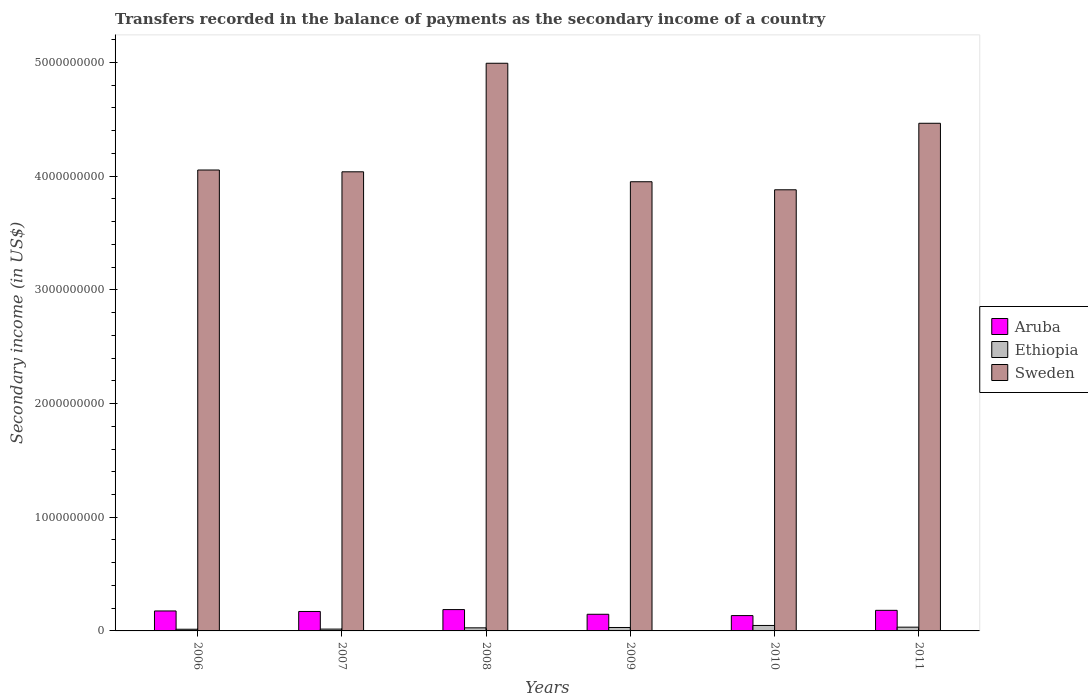How many groups of bars are there?
Offer a very short reply. 6. Are the number of bars per tick equal to the number of legend labels?
Keep it short and to the point. Yes. How many bars are there on the 4th tick from the right?
Keep it short and to the point. 3. What is the secondary income of in Ethiopia in 2007?
Make the answer very short. 1.60e+07. Across all years, what is the maximum secondary income of in Ethiopia?
Your answer should be very brief. 4.80e+07. Across all years, what is the minimum secondary income of in Ethiopia?
Give a very brief answer. 1.48e+07. In which year was the secondary income of in Sweden minimum?
Your response must be concise. 2010. What is the total secondary income of in Ethiopia in the graph?
Offer a very short reply. 1.69e+08. What is the difference between the secondary income of in Sweden in 2006 and that in 2010?
Ensure brevity in your answer.  1.74e+08. What is the difference between the secondary income of in Ethiopia in 2007 and the secondary income of in Aruba in 2010?
Offer a very short reply. -1.19e+08. What is the average secondary income of in Sweden per year?
Give a very brief answer. 4.23e+09. In the year 2009, what is the difference between the secondary income of in Aruba and secondary income of in Ethiopia?
Ensure brevity in your answer.  1.16e+08. In how many years, is the secondary income of in Aruba greater than 4200000000 US$?
Give a very brief answer. 0. What is the ratio of the secondary income of in Sweden in 2006 to that in 2011?
Provide a succinct answer. 0.91. Is the difference between the secondary income of in Aruba in 2007 and 2011 greater than the difference between the secondary income of in Ethiopia in 2007 and 2011?
Ensure brevity in your answer.  Yes. What is the difference between the highest and the second highest secondary income of in Ethiopia?
Your response must be concise. 1.49e+07. What is the difference between the highest and the lowest secondary income of in Aruba?
Your answer should be compact. 5.27e+07. In how many years, is the secondary income of in Aruba greater than the average secondary income of in Aruba taken over all years?
Provide a succinct answer. 4. Is the sum of the secondary income of in Aruba in 2008 and 2009 greater than the maximum secondary income of in Sweden across all years?
Ensure brevity in your answer.  No. What does the 3rd bar from the right in 2009 represents?
Provide a succinct answer. Aruba. Is it the case that in every year, the sum of the secondary income of in Sweden and secondary income of in Ethiopia is greater than the secondary income of in Aruba?
Your answer should be compact. Yes. Are all the bars in the graph horizontal?
Your answer should be very brief. No. How many years are there in the graph?
Keep it short and to the point. 6. Does the graph contain any zero values?
Offer a very short reply. No. How many legend labels are there?
Offer a terse response. 3. How are the legend labels stacked?
Ensure brevity in your answer.  Vertical. What is the title of the graph?
Your answer should be compact. Transfers recorded in the balance of payments as the secondary income of a country. What is the label or title of the X-axis?
Provide a short and direct response. Years. What is the label or title of the Y-axis?
Ensure brevity in your answer.  Secondary income (in US$). What is the Secondary income (in US$) in Aruba in 2006?
Ensure brevity in your answer.  1.76e+08. What is the Secondary income (in US$) of Ethiopia in 2006?
Give a very brief answer. 1.48e+07. What is the Secondary income (in US$) in Sweden in 2006?
Give a very brief answer. 4.05e+09. What is the Secondary income (in US$) of Aruba in 2007?
Offer a very short reply. 1.71e+08. What is the Secondary income (in US$) in Ethiopia in 2007?
Your answer should be very brief. 1.60e+07. What is the Secondary income (in US$) in Sweden in 2007?
Keep it short and to the point. 4.04e+09. What is the Secondary income (in US$) of Aruba in 2008?
Your answer should be very brief. 1.88e+08. What is the Secondary income (in US$) in Ethiopia in 2008?
Offer a terse response. 2.72e+07. What is the Secondary income (in US$) in Sweden in 2008?
Offer a terse response. 4.99e+09. What is the Secondary income (in US$) of Aruba in 2009?
Give a very brief answer. 1.46e+08. What is the Secondary income (in US$) of Ethiopia in 2009?
Offer a terse response. 3.02e+07. What is the Secondary income (in US$) of Sweden in 2009?
Your response must be concise. 3.95e+09. What is the Secondary income (in US$) in Aruba in 2010?
Provide a succinct answer. 1.35e+08. What is the Secondary income (in US$) of Ethiopia in 2010?
Provide a succinct answer. 4.80e+07. What is the Secondary income (in US$) of Sweden in 2010?
Your response must be concise. 3.88e+09. What is the Secondary income (in US$) in Aruba in 2011?
Provide a short and direct response. 1.81e+08. What is the Secondary income (in US$) of Ethiopia in 2011?
Offer a terse response. 3.31e+07. What is the Secondary income (in US$) in Sweden in 2011?
Your response must be concise. 4.47e+09. Across all years, what is the maximum Secondary income (in US$) in Aruba?
Make the answer very short. 1.88e+08. Across all years, what is the maximum Secondary income (in US$) of Ethiopia?
Offer a very short reply. 4.80e+07. Across all years, what is the maximum Secondary income (in US$) of Sweden?
Give a very brief answer. 4.99e+09. Across all years, what is the minimum Secondary income (in US$) of Aruba?
Your answer should be compact. 1.35e+08. Across all years, what is the minimum Secondary income (in US$) in Ethiopia?
Your response must be concise. 1.48e+07. Across all years, what is the minimum Secondary income (in US$) in Sweden?
Your response must be concise. 3.88e+09. What is the total Secondary income (in US$) of Aruba in the graph?
Offer a terse response. 9.97e+08. What is the total Secondary income (in US$) in Ethiopia in the graph?
Offer a terse response. 1.69e+08. What is the total Secondary income (in US$) in Sweden in the graph?
Give a very brief answer. 2.54e+1. What is the difference between the Secondary income (in US$) of Aruba in 2006 and that in 2007?
Offer a terse response. 4.45e+06. What is the difference between the Secondary income (in US$) in Ethiopia in 2006 and that in 2007?
Your answer should be compact. -1.21e+06. What is the difference between the Secondary income (in US$) in Sweden in 2006 and that in 2007?
Offer a very short reply. 1.58e+07. What is the difference between the Secondary income (in US$) of Aruba in 2006 and that in 2008?
Keep it short and to the point. -1.21e+07. What is the difference between the Secondary income (in US$) in Ethiopia in 2006 and that in 2008?
Your response must be concise. -1.24e+07. What is the difference between the Secondary income (in US$) of Sweden in 2006 and that in 2008?
Offer a very short reply. -9.39e+08. What is the difference between the Secondary income (in US$) in Aruba in 2006 and that in 2009?
Give a very brief answer. 2.91e+07. What is the difference between the Secondary income (in US$) of Ethiopia in 2006 and that in 2009?
Keep it short and to the point. -1.54e+07. What is the difference between the Secondary income (in US$) in Sweden in 2006 and that in 2009?
Your answer should be compact. 1.03e+08. What is the difference between the Secondary income (in US$) of Aruba in 2006 and that in 2010?
Offer a terse response. 4.06e+07. What is the difference between the Secondary income (in US$) in Ethiopia in 2006 and that in 2010?
Keep it short and to the point. -3.32e+07. What is the difference between the Secondary income (in US$) of Sweden in 2006 and that in 2010?
Provide a succinct answer. 1.74e+08. What is the difference between the Secondary income (in US$) of Aruba in 2006 and that in 2011?
Your response must be concise. -5.61e+06. What is the difference between the Secondary income (in US$) of Ethiopia in 2006 and that in 2011?
Your answer should be very brief. -1.83e+07. What is the difference between the Secondary income (in US$) of Sweden in 2006 and that in 2011?
Ensure brevity in your answer.  -4.11e+08. What is the difference between the Secondary income (in US$) of Aruba in 2007 and that in 2008?
Provide a short and direct response. -1.66e+07. What is the difference between the Secondary income (in US$) in Ethiopia in 2007 and that in 2008?
Your answer should be very brief. -1.11e+07. What is the difference between the Secondary income (in US$) of Sweden in 2007 and that in 2008?
Your answer should be very brief. -9.55e+08. What is the difference between the Secondary income (in US$) in Aruba in 2007 and that in 2009?
Offer a terse response. 2.46e+07. What is the difference between the Secondary income (in US$) in Ethiopia in 2007 and that in 2009?
Provide a short and direct response. -1.42e+07. What is the difference between the Secondary income (in US$) of Sweden in 2007 and that in 2009?
Make the answer very short. 8.74e+07. What is the difference between the Secondary income (in US$) in Aruba in 2007 and that in 2010?
Give a very brief answer. 3.61e+07. What is the difference between the Secondary income (in US$) of Ethiopia in 2007 and that in 2010?
Provide a short and direct response. -3.20e+07. What is the difference between the Secondary income (in US$) of Sweden in 2007 and that in 2010?
Make the answer very short. 1.58e+08. What is the difference between the Secondary income (in US$) of Aruba in 2007 and that in 2011?
Ensure brevity in your answer.  -1.01e+07. What is the difference between the Secondary income (in US$) of Ethiopia in 2007 and that in 2011?
Offer a very short reply. -1.71e+07. What is the difference between the Secondary income (in US$) of Sweden in 2007 and that in 2011?
Your response must be concise. -4.27e+08. What is the difference between the Secondary income (in US$) in Aruba in 2008 and that in 2009?
Make the answer very short. 4.12e+07. What is the difference between the Secondary income (in US$) in Ethiopia in 2008 and that in 2009?
Offer a very short reply. -3.04e+06. What is the difference between the Secondary income (in US$) of Sweden in 2008 and that in 2009?
Make the answer very short. 1.04e+09. What is the difference between the Secondary income (in US$) of Aruba in 2008 and that in 2010?
Give a very brief answer. 5.27e+07. What is the difference between the Secondary income (in US$) in Ethiopia in 2008 and that in 2010?
Offer a terse response. -2.08e+07. What is the difference between the Secondary income (in US$) in Sweden in 2008 and that in 2010?
Ensure brevity in your answer.  1.11e+09. What is the difference between the Secondary income (in US$) in Aruba in 2008 and that in 2011?
Your answer should be compact. 6.54e+06. What is the difference between the Secondary income (in US$) in Ethiopia in 2008 and that in 2011?
Offer a terse response. -5.93e+06. What is the difference between the Secondary income (in US$) in Sweden in 2008 and that in 2011?
Keep it short and to the point. 5.28e+08. What is the difference between the Secondary income (in US$) in Aruba in 2009 and that in 2010?
Keep it short and to the point. 1.15e+07. What is the difference between the Secondary income (in US$) of Ethiopia in 2009 and that in 2010?
Provide a short and direct response. -1.78e+07. What is the difference between the Secondary income (in US$) in Sweden in 2009 and that in 2010?
Make the answer very short. 7.08e+07. What is the difference between the Secondary income (in US$) of Aruba in 2009 and that in 2011?
Offer a very short reply. -3.47e+07. What is the difference between the Secondary income (in US$) in Ethiopia in 2009 and that in 2011?
Keep it short and to the point. -2.88e+06. What is the difference between the Secondary income (in US$) in Sweden in 2009 and that in 2011?
Your response must be concise. -5.14e+08. What is the difference between the Secondary income (in US$) of Aruba in 2010 and that in 2011?
Ensure brevity in your answer.  -4.62e+07. What is the difference between the Secondary income (in US$) in Ethiopia in 2010 and that in 2011?
Your answer should be compact. 1.49e+07. What is the difference between the Secondary income (in US$) of Sweden in 2010 and that in 2011?
Your response must be concise. -5.85e+08. What is the difference between the Secondary income (in US$) in Aruba in 2006 and the Secondary income (in US$) in Ethiopia in 2007?
Offer a terse response. 1.59e+08. What is the difference between the Secondary income (in US$) of Aruba in 2006 and the Secondary income (in US$) of Sweden in 2007?
Offer a very short reply. -3.86e+09. What is the difference between the Secondary income (in US$) in Ethiopia in 2006 and the Secondary income (in US$) in Sweden in 2007?
Provide a short and direct response. -4.02e+09. What is the difference between the Secondary income (in US$) in Aruba in 2006 and the Secondary income (in US$) in Ethiopia in 2008?
Keep it short and to the point. 1.48e+08. What is the difference between the Secondary income (in US$) of Aruba in 2006 and the Secondary income (in US$) of Sweden in 2008?
Offer a terse response. -4.82e+09. What is the difference between the Secondary income (in US$) of Ethiopia in 2006 and the Secondary income (in US$) of Sweden in 2008?
Offer a very short reply. -4.98e+09. What is the difference between the Secondary income (in US$) of Aruba in 2006 and the Secondary income (in US$) of Ethiopia in 2009?
Provide a succinct answer. 1.45e+08. What is the difference between the Secondary income (in US$) of Aruba in 2006 and the Secondary income (in US$) of Sweden in 2009?
Offer a terse response. -3.78e+09. What is the difference between the Secondary income (in US$) of Ethiopia in 2006 and the Secondary income (in US$) of Sweden in 2009?
Ensure brevity in your answer.  -3.94e+09. What is the difference between the Secondary income (in US$) of Aruba in 2006 and the Secondary income (in US$) of Ethiopia in 2010?
Your answer should be compact. 1.28e+08. What is the difference between the Secondary income (in US$) of Aruba in 2006 and the Secondary income (in US$) of Sweden in 2010?
Keep it short and to the point. -3.70e+09. What is the difference between the Secondary income (in US$) in Ethiopia in 2006 and the Secondary income (in US$) in Sweden in 2010?
Offer a very short reply. -3.87e+09. What is the difference between the Secondary income (in US$) in Aruba in 2006 and the Secondary income (in US$) in Ethiopia in 2011?
Offer a very short reply. 1.42e+08. What is the difference between the Secondary income (in US$) in Aruba in 2006 and the Secondary income (in US$) in Sweden in 2011?
Your answer should be compact. -4.29e+09. What is the difference between the Secondary income (in US$) of Ethiopia in 2006 and the Secondary income (in US$) of Sweden in 2011?
Give a very brief answer. -4.45e+09. What is the difference between the Secondary income (in US$) in Aruba in 2007 and the Secondary income (in US$) in Ethiopia in 2008?
Your response must be concise. 1.44e+08. What is the difference between the Secondary income (in US$) in Aruba in 2007 and the Secondary income (in US$) in Sweden in 2008?
Keep it short and to the point. -4.82e+09. What is the difference between the Secondary income (in US$) in Ethiopia in 2007 and the Secondary income (in US$) in Sweden in 2008?
Offer a very short reply. -4.98e+09. What is the difference between the Secondary income (in US$) in Aruba in 2007 and the Secondary income (in US$) in Ethiopia in 2009?
Your answer should be compact. 1.41e+08. What is the difference between the Secondary income (in US$) in Aruba in 2007 and the Secondary income (in US$) in Sweden in 2009?
Give a very brief answer. -3.78e+09. What is the difference between the Secondary income (in US$) of Ethiopia in 2007 and the Secondary income (in US$) of Sweden in 2009?
Give a very brief answer. -3.93e+09. What is the difference between the Secondary income (in US$) of Aruba in 2007 and the Secondary income (in US$) of Ethiopia in 2010?
Your response must be concise. 1.23e+08. What is the difference between the Secondary income (in US$) of Aruba in 2007 and the Secondary income (in US$) of Sweden in 2010?
Keep it short and to the point. -3.71e+09. What is the difference between the Secondary income (in US$) in Ethiopia in 2007 and the Secondary income (in US$) in Sweden in 2010?
Your answer should be compact. -3.86e+09. What is the difference between the Secondary income (in US$) in Aruba in 2007 and the Secondary income (in US$) in Ethiopia in 2011?
Your answer should be compact. 1.38e+08. What is the difference between the Secondary income (in US$) of Aruba in 2007 and the Secondary income (in US$) of Sweden in 2011?
Offer a very short reply. -4.29e+09. What is the difference between the Secondary income (in US$) in Ethiopia in 2007 and the Secondary income (in US$) in Sweden in 2011?
Ensure brevity in your answer.  -4.45e+09. What is the difference between the Secondary income (in US$) in Aruba in 2008 and the Secondary income (in US$) in Ethiopia in 2009?
Offer a terse response. 1.57e+08. What is the difference between the Secondary income (in US$) of Aruba in 2008 and the Secondary income (in US$) of Sweden in 2009?
Your response must be concise. -3.76e+09. What is the difference between the Secondary income (in US$) in Ethiopia in 2008 and the Secondary income (in US$) in Sweden in 2009?
Your answer should be very brief. -3.92e+09. What is the difference between the Secondary income (in US$) in Aruba in 2008 and the Secondary income (in US$) in Ethiopia in 2010?
Make the answer very short. 1.40e+08. What is the difference between the Secondary income (in US$) of Aruba in 2008 and the Secondary income (in US$) of Sweden in 2010?
Provide a succinct answer. -3.69e+09. What is the difference between the Secondary income (in US$) of Ethiopia in 2008 and the Secondary income (in US$) of Sweden in 2010?
Your answer should be compact. -3.85e+09. What is the difference between the Secondary income (in US$) of Aruba in 2008 and the Secondary income (in US$) of Ethiopia in 2011?
Your answer should be compact. 1.55e+08. What is the difference between the Secondary income (in US$) in Aruba in 2008 and the Secondary income (in US$) in Sweden in 2011?
Ensure brevity in your answer.  -4.28e+09. What is the difference between the Secondary income (in US$) in Ethiopia in 2008 and the Secondary income (in US$) in Sweden in 2011?
Make the answer very short. -4.44e+09. What is the difference between the Secondary income (in US$) of Aruba in 2009 and the Secondary income (in US$) of Ethiopia in 2010?
Offer a very short reply. 9.85e+07. What is the difference between the Secondary income (in US$) of Aruba in 2009 and the Secondary income (in US$) of Sweden in 2010?
Offer a very short reply. -3.73e+09. What is the difference between the Secondary income (in US$) of Ethiopia in 2009 and the Secondary income (in US$) of Sweden in 2010?
Make the answer very short. -3.85e+09. What is the difference between the Secondary income (in US$) in Aruba in 2009 and the Secondary income (in US$) in Ethiopia in 2011?
Keep it short and to the point. 1.13e+08. What is the difference between the Secondary income (in US$) of Aruba in 2009 and the Secondary income (in US$) of Sweden in 2011?
Ensure brevity in your answer.  -4.32e+09. What is the difference between the Secondary income (in US$) of Ethiopia in 2009 and the Secondary income (in US$) of Sweden in 2011?
Your answer should be compact. -4.43e+09. What is the difference between the Secondary income (in US$) in Aruba in 2010 and the Secondary income (in US$) in Ethiopia in 2011?
Your response must be concise. 1.02e+08. What is the difference between the Secondary income (in US$) of Aruba in 2010 and the Secondary income (in US$) of Sweden in 2011?
Keep it short and to the point. -4.33e+09. What is the difference between the Secondary income (in US$) in Ethiopia in 2010 and the Secondary income (in US$) in Sweden in 2011?
Provide a short and direct response. -4.42e+09. What is the average Secondary income (in US$) of Aruba per year?
Your answer should be compact. 1.66e+08. What is the average Secondary income (in US$) of Ethiopia per year?
Make the answer very short. 2.82e+07. What is the average Secondary income (in US$) in Sweden per year?
Ensure brevity in your answer.  4.23e+09. In the year 2006, what is the difference between the Secondary income (in US$) in Aruba and Secondary income (in US$) in Ethiopia?
Give a very brief answer. 1.61e+08. In the year 2006, what is the difference between the Secondary income (in US$) in Aruba and Secondary income (in US$) in Sweden?
Your answer should be compact. -3.88e+09. In the year 2006, what is the difference between the Secondary income (in US$) of Ethiopia and Secondary income (in US$) of Sweden?
Offer a very short reply. -4.04e+09. In the year 2007, what is the difference between the Secondary income (in US$) in Aruba and Secondary income (in US$) in Ethiopia?
Ensure brevity in your answer.  1.55e+08. In the year 2007, what is the difference between the Secondary income (in US$) in Aruba and Secondary income (in US$) in Sweden?
Offer a terse response. -3.87e+09. In the year 2007, what is the difference between the Secondary income (in US$) of Ethiopia and Secondary income (in US$) of Sweden?
Ensure brevity in your answer.  -4.02e+09. In the year 2008, what is the difference between the Secondary income (in US$) of Aruba and Secondary income (in US$) of Ethiopia?
Provide a succinct answer. 1.60e+08. In the year 2008, what is the difference between the Secondary income (in US$) of Aruba and Secondary income (in US$) of Sweden?
Your answer should be very brief. -4.81e+09. In the year 2008, what is the difference between the Secondary income (in US$) in Ethiopia and Secondary income (in US$) in Sweden?
Your answer should be very brief. -4.97e+09. In the year 2009, what is the difference between the Secondary income (in US$) in Aruba and Secondary income (in US$) in Ethiopia?
Your answer should be compact. 1.16e+08. In the year 2009, what is the difference between the Secondary income (in US$) of Aruba and Secondary income (in US$) of Sweden?
Provide a succinct answer. -3.80e+09. In the year 2009, what is the difference between the Secondary income (in US$) of Ethiopia and Secondary income (in US$) of Sweden?
Ensure brevity in your answer.  -3.92e+09. In the year 2010, what is the difference between the Secondary income (in US$) in Aruba and Secondary income (in US$) in Ethiopia?
Your response must be concise. 8.70e+07. In the year 2010, what is the difference between the Secondary income (in US$) of Aruba and Secondary income (in US$) of Sweden?
Offer a very short reply. -3.75e+09. In the year 2010, what is the difference between the Secondary income (in US$) of Ethiopia and Secondary income (in US$) of Sweden?
Keep it short and to the point. -3.83e+09. In the year 2011, what is the difference between the Secondary income (in US$) of Aruba and Secondary income (in US$) of Ethiopia?
Keep it short and to the point. 1.48e+08. In the year 2011, what is the difference between the Secondary income (in US$) of Aruba and Secondary income (in US$) of Sweden?
Offer a very short reply. -4.28e+09. In the year 2011, what is the difference between the Secondary income (in US$) in Ethiopia and Secondary income (in US$) in Sweden?
Ensure brevity in your answer.  -4.43e+09. What is the ratio of the Secondary income (in US$) of Ethiopia in 2006 to that in 2007?
Your response must be concise. 0.92. What is the ratio of the Secondary income (in US$) of Aruba in 2006 to that in 2008?
Offer a terse response. 0.94. What is the ratio of the Secondary income (in US$) in Ethiopia in 2006 to that in 2008?
Your answer should be very brief. 0.55. What is the ratio of the Secondary income (in US$) in Sweden in 2006 to that in 2008?
Your answer should be very brief. 0.81. What is the ratio of the Secondary income (in US$) in Aruba in 2006 to that in 2009?
Provide a short and direct response. 1.2. What is the ratio of the Secondary income (in US$) in Ethiopia in 2006 to that in 2009?
Offer a terse response. 0.49. What is the ratio of the Secondary income (in US$) of Sweden in 2006 to that in 2009?
Make the answer very short. 1.03. What is the ratio of the Secondary income (in US$) of Aruba in 2006 to that in 2010?
Keep it short and to the point. 1.3. What is the ratio of the Secondary income (in US$) in Ethiopia in 2006 to that in 2010?
Keep it short and to the point. 0.31. What is the ratio of the Secondary income (in US$) in Sweden in 2006 to that in 2010?
Your answer should be compact. 1.04. What is the ratio of the Secondary income (in US$) of Ethiopia in 2006 to that in 2011?
Make the answer very short. 0.45. What is the ratio of the Secondary income (in US$) of Sweden in 2006 to that in 2011?
Your answer should be compact. 0.91. What is the ratio of the Secondary income (in US$) of Aruba in 2007 to that in 2008?
Make the answer very short. 0.91. What is the ratio of the Secondary income (in US$) of Ethiopia in 2007 to that in 2008?
Provide a succinct answer. 0.59. What is the ratio of the Secondary income (in US$) in Sweden in 2007 to that in 2008?
Your answer should be compact. 0.81. What is the ratio of the Secondary income (in US$) of Aruba in 2007 to that in 2009?
Your answer should be very brief. 1.17. What is the ratio of the Secondary income (in US$) in Ethiopia in 2007 to that in 2009?
Offer a very short reply. 0.53. What is the ratio of the Secondary income (in US$) of Sweden in 2007 to that in 2009?
Your response must be concise. 1.02. What is the ratio of the Secondary income (in US$) in Aruba in 2007 to that in 2010?
Your answer should be compact. 1.27. What is the ratio of the Secondary income (in US$) in Ethiopia in 2007 to that in 2010?
Provide a succinct answer. 0.33. What is the ratio of the Secondary income (in US$) in Sweden in 2007 to that in 2010?
Ensure brevity in your answer.  1.04. What is the ratio of the Secondary income (in US$) of Aruba in 2007 to that in 2011?
Provide a succinct answer. 0.94. What is the ratio of the Secondary income (in US$) of Ethiopia in 2007 to that in 2011?
Provide a short and direct response. 0.48. What is the ratio of the Secondary income (in US$) in Sweden in 2007 to that in 2011?
Ensure brevity in your answer.  0.9. What is the ratio of the Secondary income (in US$) of Aruba in 2008 to that in 2009?
Give a very brief answer. 1.28. What is the ratio of the Secondary income (in US$) in Ethiopia in 2008 to that in 2009?
Make the answer very short. 0.9. What is the ratio of the Secondary income (in US$) in Sweden in 2008 to that in 2009?
Provide a succinct answer. 1.26. What is the ratio of the Secondary income (in US$) of Aruba in 2008 to that in 2010?
Your answer should be compact. 1.39. What is the ratio of the Secondary income (in US$) of Ethiopia in 2008 to that in 2010?
Provide a short and direct response. 0.57. What is the ratio of the Secondary income (in US$) of Sweden in 2008 to that in 2010?
Give a very brief answer. 1.29. What is the ratio of the Secondary income (in US$) of Aruba in 2008 to that in 2011?
Offer a very short reply. 1.04. What is the ratio of the Secondary income (in US$) in Ethiopia in 2008 to that in 2011?
Keep it short and to the point. 0.82. What is the ratio of the Secondary income (in US$) of Sweden in 2008 to that in 2011?
Offer a very short reply. 1.12. What is the ratio of the Secondary income (in US$) in Aruba in 2009 to that in 2010?
Offer a terse response. 1.09. What is the ratio of the Secondary income (in US$) of Ethiopia in 2009 to that in 2010?
Your answer should be compact. 0.63. What is the ratio of the Secondary income (in US$) in Sweden in 2009 to that in 2010?
Give a very brief answer. 1.02. What is the ratio of the Secondary income (in US$) in Aruba in 2009 to that in 2011?
Ensure brevity in your answer.  0.81. What is the ratio of the Secondary income (in US$) in Ethiopia in 2009 to that in 2011?
Offer a very short reply. 0.91. What is the ratio of the Secondary income (in US$) of Sweden in 2009 to that in 2011?
Offer a terse response. 0.88. What is the ratio of the Secondary income (in US$) of Aruba in 2010 to that in 2011?
Offer a terse response. 0.74. What is the ratio of the Secondary income (in US$) of Ethiopia in 2010 to that in 2011?
Provide a short and direct response. 1.45. What is the ratio of the Secondary income (in US$) of Sweden in 2010 to that in 2011?
Provide a succinct answer. 0.87. What is the difference between the highest and the second highest Secondary income (in US$) in Aruba?
Offer a terse response. 6.54e+06. What is the difference between the highest and the second highest Secondary income (in US$) in Ethiopia?
Provide a short and direct response. 1.49e+07. What is the difference between the highest and the second highest Secondary income (in US$) in Sweden?
Keep it short and to the point. 5.28e+08. What is the difference between the highest and the lowest Secondary income (in US$) of Aruba?
Provide a succinct answer. 5.27e+07. What is the difference between the highest and the lowest Secondary income (in US$) of Ethiopia?
Keep it short and to the point. 3.32e+07. What is the difference between the highest and the lowest Secondary income (in US$) of Sweden?
Your answer should be compact. 1.11e+09. 